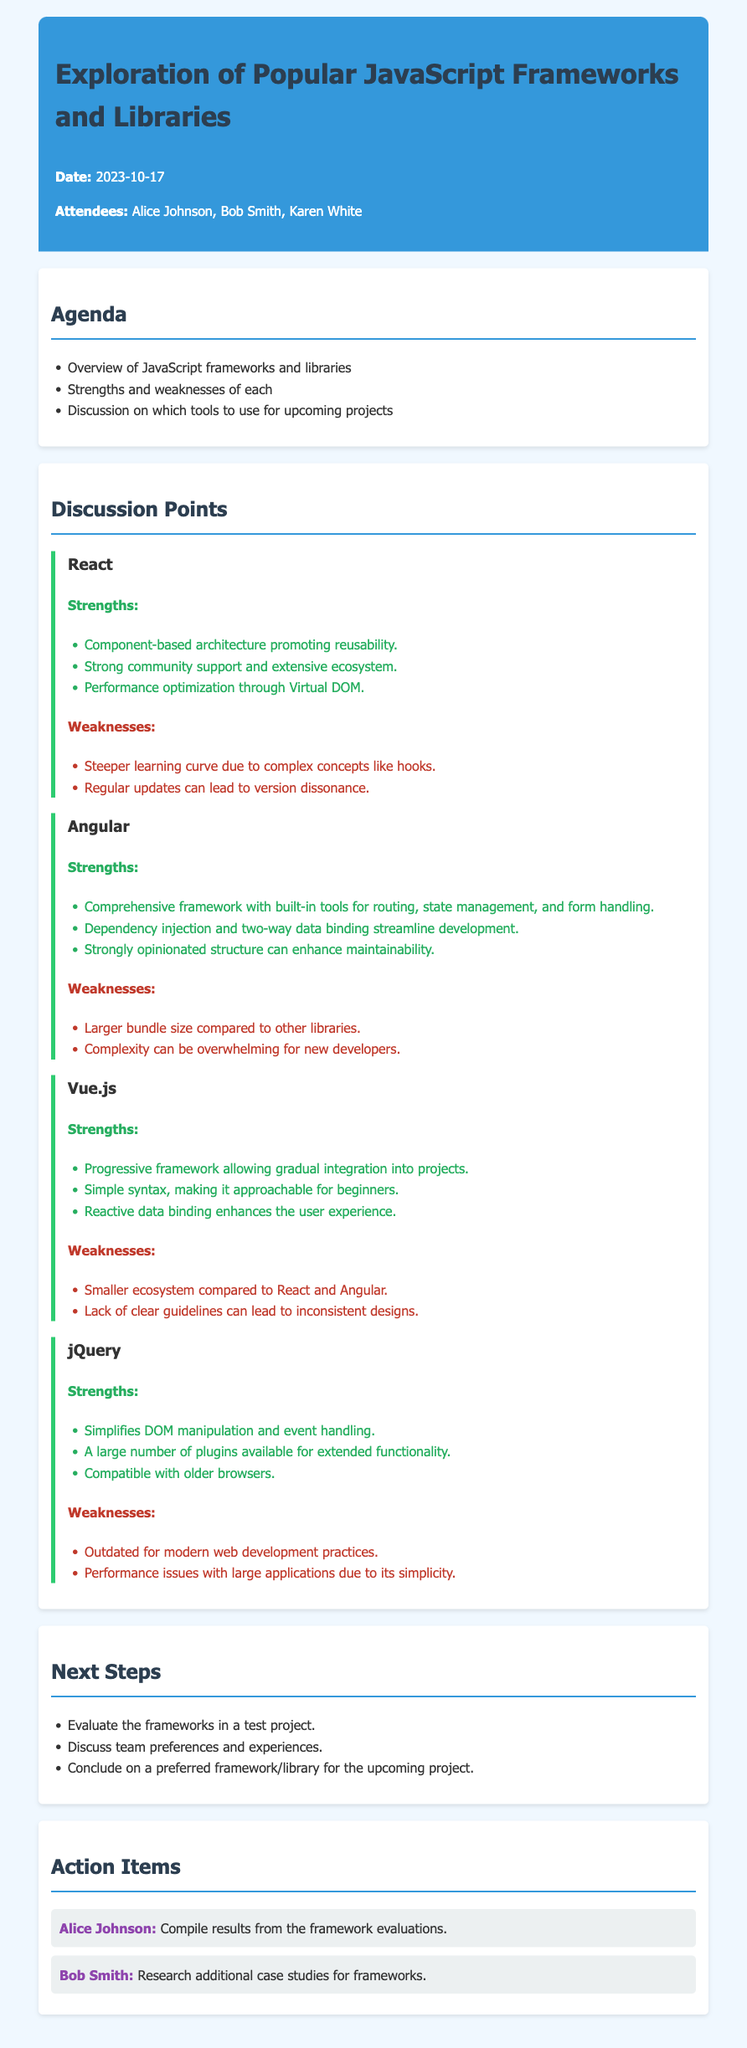What is the date of the meeting? The date is clearly mentioned in the document header under "Date."
Answer: 2023-10-17 Who is responsible for compiling results from the framework evaluations? This information is found in the "Action Items" section where each person's responsibilities are outlined.
Answer: Alice Johnson What is a strength of React? The strengths of React are detailed in its section, listing multiple points; one example is chosen for this question.
Answer: Component-based architecture promoting reusability What is a weakness of Angular? The weaknesses of Angular are listed in bullet points; one example is chosen for this question.
Answer: Larger bundle size compared to other libraries Which frameworks were discussed in the meeting? The frameworks are listed under "Discussion Points," summing all the discussed tools.
Answer: React, Angular, Vue.js, jQuery What is a unique feature of Vue.js? One specific strength of Vue.js is mentioned which illustrates its unique characteristic.
Answer: Progressive framework allowing gradual integration into projects What is an action item for Bob Smith? This information is found in the "Action Items" section, where Bob Smith's responsibilities are defined.
Answer: Research additional case studies for frameworks How many attendees were present at the meeting? Attendees are listed in the document header, allowing for a straightforward count.
Answer: Three 